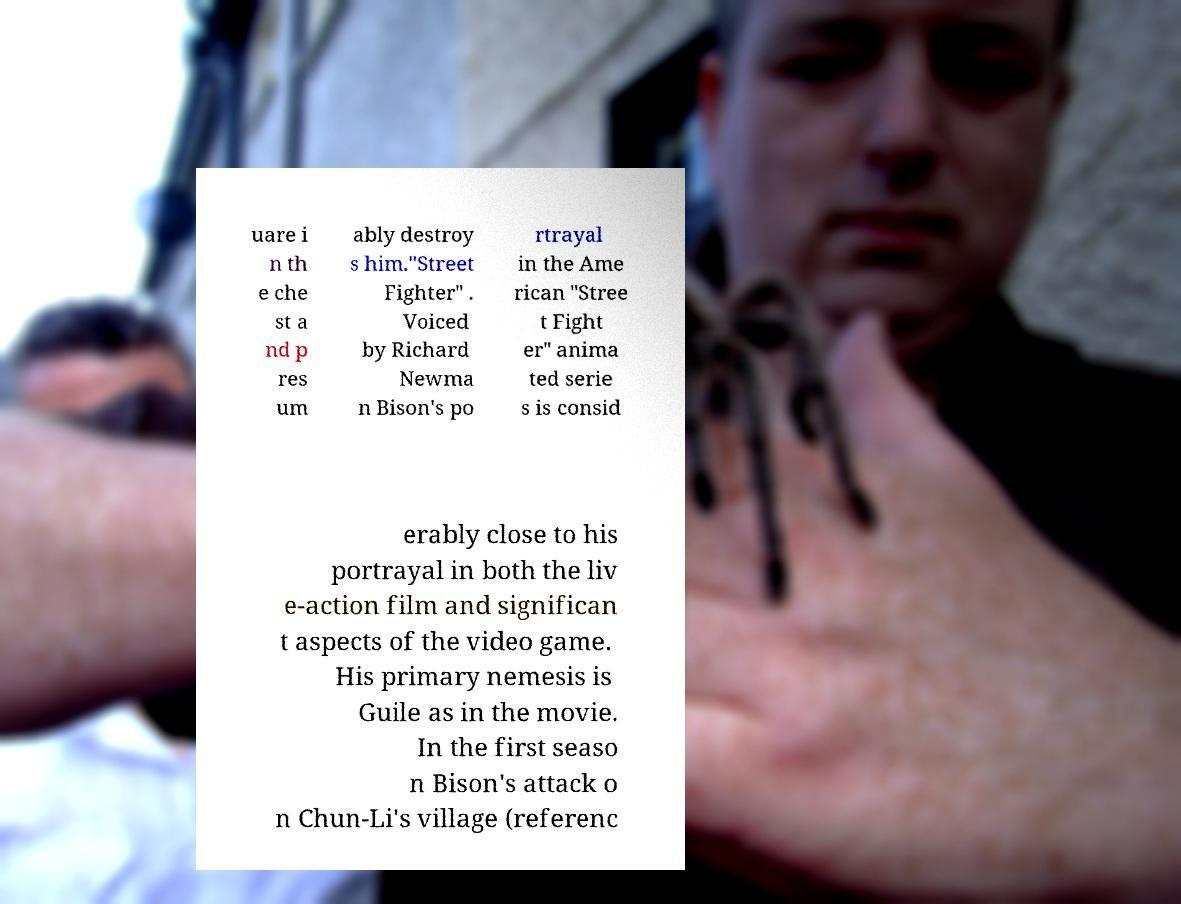Could you extract and type out the text from this image? uare i n th e che st a nd p res um ably destroy s him."Street Fighter" . Voiced by Richard Newma n Bison's po rtrayal in the Ame rican "Stree t Fight er" anima ted serie s is consid erably close to his portrayal in both the liv e-action film and significan t aspects of the video game. His primary nemesis is Guile as in the movie. In the first seaso n Bison's attack o n Chun-Li's village (referenc 